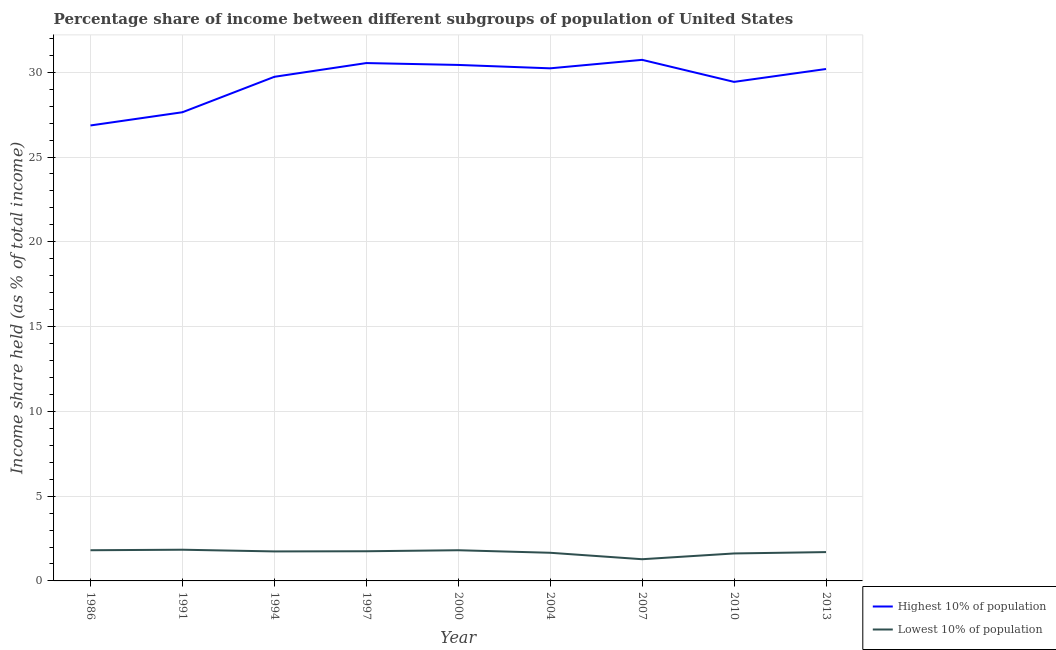Is the number of lines equal to the number of legend labels?
Your response must be concise. Yes. What is the income share held by lowest 10% of the population in 2004?
Ensure brevity in your answer.  1.66. Across all years, what is the maximum income share held by lowest 10% of the population?
Your answer should be very brief. 1.84. Across all years, what is the minimum income share held by highest 10% of the population?
Offer a terse response. 26.86. In which year was the income share held by highest 10% of the population maximum?
Give a very brief answer. 2007. What is the total income share held by highest 10% of the population in the graph?
Your answer should be very brief. 265.78. What is the difference between the income share held by highest 10% of the population in 2000 and that in 2013?
Offer a very short reply. 0.24. What is the difference between the income share held by lowest 10% of the population in 1997 and the income share held by highest 10% of the population in 2013?
Provide a short and direct response. -28.44. What is the average income share held by lowest 10% of the population per year?
Provide a succinct answer. 1.69. In the year 1994, what is the difference between the income share held by highest 10% of the population and income share held by lowest 10% of the population?
Make the answer very short. 27.99. What is the ratio of the income share held by lowest 10% of the population in 2010 to that in 2013?
Offer a terse response. 0.95. What is the difference between the highest and the second highest income share held by highest 10% of the population?
Your response must be concise. 0.19. What is the difference between the highest and the lowest income share held by highest 10% of the population?
Your answer should be very brief. 3.87. In how many years, is the income share held by highest 10% of the population greater than the average income share held by highest 10% of the population taken over all years?
Offer a terse response. 6. Does the income share held by highest 10% of the population monotonically increase over the years?
Offer a terse response. No. Is the income share held by highest 10% of the population strictly greater than the income share held by lowest 10% of the population over the years?
Give a very brief answer. Yes. Is the income share held by lowest 10% of the population strictly less than the income share held by highest 10% of the population over the years?
Make the answer very short. Yes. Are the values on the major ticks of Y-axis written in scientific E-notation?
Your response must be concise. No. Where does the legend appear in the graph?
Make the answer very short. Bottom right. How many legend labels are there?
Offer a very short reply. 2. What is the title of the graph?
Your response must be concise. Percentage share of income between different subgroups of population of United States. What is the label or title of the Y-axis?
Your response must be concise. Income share held (as % of total income). What is the Income share held (as % of total income) in Highest 10% of population in 1986?
Keep it short and to the point. 26.86. What is the Income share held (as % of total income) in Lowest 10% of population in 1986?
Provide a succinct answer. 1.81. What is the Income share held (as % of total income) in Highest 10% of population in 1991?
Ensure brevity in your answer.  27.64. What is the Income share held (as % of total income) of Lowest 10% of population in 1991?
Keep it short and to the point. 1.84. What is the Income share held (as % of total income) of Highest 10% of population in 1994?
Provide a short and direct response. 29.73. What is the Income share held (as % of total income) of Lowest 10% of population in 1994?
Your answer should be very brief. 1.74. What is the Income share held (as % of total income) of Highest 10% of population in 1997?
Provide a short and direct response. 30.54. What is the Income share held (as % of total income) of Lowest 10% of population in 1997?
Provide a short and direct response. 1.75. What is the Income share held (as % of total income) in Highest 10% of population in 2000?
Offer a very short reply. 30.43. What is the Income share held (as % of total income) in Lowest 10% of population in 2000?
Provide a succinct answer. 1.81. What is the Income share held (as % of total income) of Highest 10% of population in 2004?
Offer a terse response. 30.23. What is the Income share held (as % of total income) in Lowest 10% of population in 2004?
Provide a short and direct response. 1.66. What is the Income share held (as % of total income) in Highest 10% of population in 2007?
Ensure brevity in your answer.  30.73. What is the Income share held (as % of total income) in Lowest 10% of population in 2007?
Make the answer very short. 1.28. What is the Income share held (as % of total income) of Highest 10% of population in 2010?
Provide a short and direct response. 29.43. What is the Income share held (as % of total income) of Lowest 10% of population in 2010?
Ensure brevity in your answer.  1.62. What is the Income share held (as % of total income) in Highest 10% of population in 2013?
Provide a succinct answer. 30.19. Across all years, what is the maximum Income share held (as % of total income) in Highest 10% of population?
Keep it short and to the point. 30.73. Across all years, what is the maximum Income share held (as % of total income) of Lowest 10% of population?
Provide a short and direct response. 1.84. Across all years, what is the minimum Income share held (as % of total income) in Highest 10% of population?
Ensure brevity in your answer.  26.86. Across all years, what is the minimum Income share held (as % of total income) in Lowest 10% of population?
Make the answer very short. 1.28. What is the total Income share held (as % of total income) in Highest 10% of population in the graph?
Give a very brief answer. 265.78. What is the total Income share held (as % of total income) in Lowest 10% of population in the graph?
Provide a succinct answer. 15.21. What is the difference between the Income share held (as % of total income) of Highest 10% of population in 1986 and that in 1991?
Your answer should be compact. -0.78. What is the difference between the Income share held (as % of total income) in Lowest 10% of population in 1986 and that in 1991?
Offer a very short reply. -0.03. What is the difference between the Income share held (as % of total income) of Highest 10% of population in 1986 and that in 1994?
Offer a very short reply. -2.87. What is the difference between the Income share held (as % of total income) in Lowest 10% of population in 1986 and that in 1994?
Keep it short and to the point. 0.07. What is the difference between the Income share held (as % of total income) of Highest 10% of population in 1986 and that in 1997?
Your answer should be very brief. -3.68. What is the difference between the Income share held (as % of total income) of Lowest 10% of population in 1986 and that in 1997?
Offer a terse response. 0.06. What is the difference between the Income share held (as % of total income) in Highest 10% of population in 1986 and that in 2000?
Provide a short and direct response. -3.57. What is the difference between the Income share held (as % of total income) of Highest 10% of population in 1986 and that in 2004?
Offer a terse response. -3.37. What is the difference between the Income share held (as % of total income) in Highest 10% of population in 1986 and that in 2007?
Your answer should be very brief. -3.87. What is the difference between the Income share held (as % of total income) of Lowest 10% of population in 1986 and that in 2007?
Keep it short and to the point. 0.53. What is the difference between the Income share held (as % of total income) of Highest 10% of population in 1986 and that in 2010?
Offer a very short reply. -2.57. What is the difference between the Income share held (as % of total income) of Lowest 10% of population in 1986 and that in 2010?
Your response must be concise. 0.19. What is the difference between the Income share held (as % of total income) in Highest 10% of population in 1986 and that in 2013?
Offer a terse response. -3.33. What is the difference between the Income share held (as % of total income) of Lowest 10% of population in 1986 and that in 2013?
Give a very brief answer. 0.11. What is the difference between the Income share held (as % of total income) in Highest 10% of population in 1991 and that in 1994?
Keep it short and to the point. -2.09. What is the difference between the Income share held (as % of total income) of Lowest 10% of population in 1991 and that in 1994?
Give a very brief answer. 0.1. What is the difference between the Income share held (as % of total income) in Highest 10% of population in 1991 and that in 1997?
Your response must be concise. -2.9. What is the difference between the Income share held (as % of total income) of Lowest 10% of population in 1991 and that in 1997?
Offer a terse response. 0.09. What is the difference between the Income share held (as % of total income) in Highest 10% of population in 1991 and that in 2000?
Your response must be concise. -2.79. What is the difference between the Income share held (as % of total income) of Highest 10% of population in 1991 and that in 2004?
Your answer should be very brief. -2.59. What is the difference between the Income share held (as % of total income) of Lowest 10% of population in 1991 and that in 2004?
Offer a terse response. 0.18. What is the difference between the Income share held (as % of total income) of Highest 10% of population in 1991 and that in 2007?
Your response must be concise. -3.09. What is the difference between the Income share held (as % of total income) in Lowest 10% of population in 1991 and that in 2007?
Your answer should be very brief. 0.56. What is the difference between the Income share held (as % of total income) in Highest 10% of population in 1991 and that in 2010?
Make the answer very short. -1.79. What is the difference between the Income share held (as % of total income) in Lowest 10% of population in 1991 and that in 2010?
Make the answer very short. 0.22. What is the difference between the Income share held (as % of total income) of Highest 10% of population in 1991 and that in 2013?
Your answer should be compact. -2.55. What is the difference between the Income share held (as % of total income) in Lowest 10% of population in 1991 and that in 2013?
Your response must be concise. 0.14. What is the difference between the Income share held (as % of total income) in Highest 10% of population in 1994 and that in 1997?
Offer a very short reply. -0.81. What is the difference between the Income share held (as % of total income) in Lowest 10% of population in 1994 and that in 1997?
Offer a very short reply. -0.01. What is the difference between the Income share held (as % of total income) of Lowest 10% of population in 1994 and that in 2000?
Offer a terse response. -0.07. What is the difference between the Income share held (as % of total income) in Highest 10% of population in 1994 and that in 2004?
Offer a very short reply. -0.5. What is the difference between the Income share held (as % of total income) in Lowest 10% of population in 1994 and that in 2004?
Keep it short and to the point. 0.08. What is the difference between the Income share held (as % of total income) of Lowest 10% of population in 1994 and that in 2007?
Your answer should be compact. 0.46. What is the difference between the Income share held (as % of total income) in Highest 10% of population in 1994 and that in 2010?
Make the answer very short. 0.3. What is the difference between the Income share held (as % of total income) in Lowest 10% of population in 1994 and that in 2010?
Give a very brief answer. 0.12. What is the difference between the Income share held (as % of total income) of Highest 10% of population in 1994 and that in 2013?
Offer a terse response. -0.46. What is the difference between the Income share held (as % of total income) in Highest 10% of population in 1997 and that in 2000?
Provide a succinct answer. 0.11. What is the difference between the Income share held (as % of total income) in Lowest 10% of population in 1997 and that in 2000?
Offer a very short reply. -0.06. What is the difference between the Income share held (as % of total income) in Highest 10% of population in 1997 and that in 2004?
Make the answer very short. 0.31. What is the difference between the Income share held (as % of total income) of Lowest 10% of population in 1997 and that in 2004?
Your response must be concise. 0.09. What is the difference between the Income share held (as % of total income) in Highest 10% of population in 1997 and that in 2007?
Your response must be concise. -0.19. What is the difference between the Income share held (as % of total income) in Lowest 10% of population in 1997 and that in 2007?
Ensure brevity in your answer.  0.47. What is the difference between the Income share held (as % of total income) of Highest 10% of population in 1997 and that in 2010?
Give a very brief answer. 1.11. What is the difference between the Income share held (as % of total income) of Lowest 10% of population in 1997 and that in 2010?
Keep it short and to the point. 0.13. What is the difference between the Income share held (as % of total income) of Highest 10% of population in 1997 and that in 2013?
Offer a terse response. 0.35. What is the difference between the Income share held (as % of total income) in Lowest 10% of population in 1997 and that in 2013?
Give a very brief answer. 0.05. What is the difference between the Income share held (as % of total income) in Lowest 10% of population in 2000 and that in 2007?
Make the answer very short. 0.53. What is the difference between the Income share held (as % of total income) in Highest 10% of population in 2000 and that in 2010?
Provide a short and direct response. 1. What is the difference between the Income share held (as % of total income) in Lowest 10% of population in 2000 and that in 2010?
Your answer should be compact. 0.19. What is the difference between the Income share held (as % of total income) of Highest 10% of population in 2000 and that in 2013?
Make the answer very short. 0.24. What is the difference between the Income share held (as % of total income) of Lowest 10% of population in 2000 and that in 2013?
Your answer should be compact. 0.11. What is the difference between the Income share held (as % of total income) of Lowest 10% of population in 2004 and that in 2007?
Ensure brevity in your answer.  0.38. What is the difference between the Income share held (as % of total income) in Lowest 10% of population in 2004 and that in 2010?
Keep it short and to the point. 0.04. What is the difference between the Income share held (as % of total income) in Highest 10% of population in 2004 and that in 2013?
Provide a short and direct response. 0.04. What is the difference between the Income share held (as % of total income) of Lowest 10% of population in 2004 and that in 2013?
Make the answer very short. -0.04. What is the difference between the Income share held (as % of total income) of Lowest 10% of population in 2007 and that in 2010?
Ensure brevity in your answer.  -0.34. What is the difference between the Income share held (as % of total income) of Highest 10% of population in 2007 and that in 2013?
Your response must be concise. 0.54. What is the difference between the Income share held (as % of total income) in Lowest 10% of population in 2007 and that in 2013?
Provide a succinct answer. -0.42. What is the difference between the Income share held (as % of total income) in Highest 10% of population in 2010 and that in 2013?
Provide a short and direct response. -0.76. What is the difference between the Income share held (as % of total income) in Lowest 10% of population in 2010 and that in 2013?
Ensure brevity in your answer.  -0.08. What is the difference between the Income share held (as % of total income) in Highest 10% of population in 1986 and the Income share held (as % of total income) in Lowest 10% of population in 1991?
Your response must be concise. 25.02. What is the difference between the Income share held (as % of total income) of Highest 10% of population in 1986 and the Income share held (as % of total income) of Lowest 10% of population in 1994?
Keep it short and to the point. 25.12. What is the difference between the Income share held (as % of total income) in Highest 10% of population in 1986 and the Income share held (as % of total income) in Lowest 10% of population in 1997?
Your response must be concise. 25.11. What is the difference between the Income share held (as % of total income) in Highest 10% of population in 1986 and the Income share held (as % of total income) in Lowest 10% of population in 2000?
Offer a very short reply. 25.05. What is the difference between the Income share held (as % of total income) in Highest 10% of population in 1986 and the Income share held (as % of total income) in Lowest 10% of population in 2004?
Offer a terse response. 25.2. What is the difference between the Income share held (as % of total income) of Highest 10% of population in 1986 and the Income share held (as % of total income) of Lowest 10% of population in 2007?
Ensure brevity in your answer.  25.58. What is the difference between the Income share held (as % of total income) in Highest 10% of population in 1986 and the Income share held (as % of total income) in Lowest 10% of population in 2010?
Your response must be concise. 25.24. What is the difference between the Income share held (as % of total income) in Highest 10% of population in 1986 and the Income share held (as % of total income) in Lowest 10% of population in 2013?
Your answer should be compact. 25.16. What is the difference between the Income share held (as % of total income) of Highest 10% of population in 1991 and the Income share held (as % of total income) of Lowest 10% of population in 1994?
Give a very brief answer. 25.9. What is the difference between the Income share held (as % of total income) in Highest 10% of population in 1991 and the Income share held (as % of total income) in Lowest 10% of population in 1997?
Your answer should be very brief. 25.89. What is the difference between the Income share held (as % of total income) of Highest 10% of population in 1991 and the Income share held (as % of total income) of Lowest 10% of population in 2000?
Keep it short and to the point. 25.83. What is the difference between the Income share held (as % of total income) of Highest 10% of population in 1991 and the Income share held (as % of total income) of Lowest 10% of population in 2004?
Your response must be concise. 25.98. What is the difference between the Income share held (as % of total income) of Highest 10% of population in 1991 and the Income share held (as % of total income) of Lowest 10% of population in 2007?
Provide a short and direct response. 26.36. What is the difference between the Income share held (as % of total income) of Highest 10% of population in 1991 and the Income share held (as % of total income) of Lowest 10% of population in 2010?
Offer a terse response. 26.02. What is the difference between the Income share held (as % of total income) in Highest 10% of population in 1991 and the Income share held (as % of total income) in Lowest 10% of population in 2013?
Offer a very short reply. 25.94. What is the difference between the Income share held (as % of total income) of Highest 10% of population in 1994 and the Income share held (as % of total income) of Lowest 10% of population in 1997?
Offer a terse response. 27.98. What is the difference between the Income share held (as % of total income) of Highest 10% of population in 1994 and the Income share held (as % of total income) of Lowest 10% of population in 2000?
Provide a short and direct response. 27.92. What is the difference between the Income share held (as % of total income) in Highest 10% of population in 1994 and the Income share held (as % of total income) in Lowest 10% of population in 2004?
Provide a short and direct response. 28.07. What is the difference between the Income share held (as % of total income) of Highest 10% of population in 1994 and the Income share held (as % of total income) of Lowest 10% of population in 2007?
Give a very brief answer. 28.45. What is the difference between the Income share held (as % of total income) of Highest 10% of population in 1994 and the Income share held (as % of total income) of Lowest 10% of population in 2010?
Ensure brevity in your answer.  28.11. What is the difference between the Income share held (as % of total income) in Highest 10% of population in 1994 and the Income share held (as % of total income) in Lowest 10% of population in 2013?
Offer a terse response. 28.03. What is the difference between the Income share held (as % of total income) of Highest 10% of population in 1997 and the Income share held (as % of total income) of Lowest 10% of population in 2000?
Give a very brief answer. 28.73. What is the difference between the Income share held (as % of total income) of Highest 10% of population in 1997 and the Income share held (as % of total income) of Lowest 10% of population in 2004?
Give a very brief answer. 28.88. What is the difference between the Income share held (as % of total income) of Highest 10% of population in 1997 and the Income share held (as % of total income) of Lowest 10% of population in 2007?
Your answer should be compact. 29.26. What is the difference between the Income share held (as % of total income) in Highest 10% of population in 1997 and the Income share held (as % of total income) in Lowest 10% of population in 2010?
Make the answer very short. 28.92. What is the difference between the Income share held (as % of total income) in Highest 10% of population in 1997 and the Income share held (as % of total income) in Lowest 10% of population in 2013?
Your response must be concise. 28.84. What is the difference between the Income share held (as % of total income) in Highest 10% of population in 2000 and the Income share held (as % of total income) in Lowest 10% of population in 2004?
Make the answer very short. 28.77. What is the difference between the Income share held (as % of total income) of Highest 10% of population in 2000 and the Income share held (as % of total income) of Lowest 10% of population in 2007?
Your answer should be compact. 29.15. What is the difference between the Income share held (as % of total income) of Highest 10% of population in 2000 and the Income share held (as % of total income) of Lowest 10% of population in 2010?
Offer a terse response. 28.81. What is the difference between the Income share held (as % of total income) of Highest 10% of population in 2000 and the Income share held (as % of total income) of Lowest 10% of population in 2013?
Provide a succinct answer. 28.73. What is the difference between the Income share held (as % of total income) in Highest 10% of population in 2004 and the Income share held (as % of total income) in Lowest 10% of population in 2007?
Offer a terse response. 28.95. What is the difference between the Income share held (as % of total income) of Highest 10% of population in 2004 and the Income share held (as % of total income) of Lowest 10% of population in 2010?
Offer a terse response. 28.61. What is the difference between the Income share held (as % of total income) of Highest 10% of population in 2004 and the Income share held (as % of total income) of Lowest 10% of population in 2013?
Your answer should be very brief. 28.53. What is the difference between the Income share held (as % of total income) of Highest 10% of population in 2007 and the Income share held (as % of total income) of Lowest 10% of population in 2010?
Give a very brief answer. 29.11. What is the difference between the Income share held (as % of total income) of Highest 10% of population in 2007 and the Income share held (as % of total income) of Lowest 10% of population in 2013?
Provide a short and direct response. 29.03. What is the difference between the Income share held (as % of total income) of Highest 10% of population in 2010 and the Income share held (as % of total income) of Lowest 10% of population in 2013?
Your answer should be compact. 27.73. What is the average Income share held (as % of total income) in Highest 10% of population per year?
Your answer should be very brief. 29.53. What is the average Income share held (as % of total income) of Lowest 10% of population per year?
Keep it short and to the point. 1.69. In the year 1986, what is the difference between the Income share held (as % of total income) in Highest 10% of population and Income share held (as % of total income) in Lowest 10% of population?
Give a very brief answer. 25.05. In the year 1991, what is the difference between the Income share held (as % of total income) in Highest 10% of population and Income share held (as % of total income) in Lowest 10% of population?
Offer a terse response. 25.8. In the year 1994, what is the difference between the Income share held (as % of total income) in Highest 10% of population and Income share held (as % of total income) in Lowest 10% of population?
Your response must be concise. 27.99. In the year 1997, what is the difference between the Income share held (as % of total income) of Highest 10% of population and Income share held (as % of total income) of Lowest 10% of population?
Offer a very short reply. 28.79. In the year 2000, what is the difference between the Income share held (as % of total income) of Highest 10% of population and Income share held (as % of total income) of Lowest 10% of population?
Ensure brevity in your answer.  28.62. In the year 2004, what is the difference between the Income share held (as % of total income) of Highest 10% of population and Income share held (as % of total income) of Lowest 10% of population?
Offer a terse response. 28.57. In the year 2007, what is the difference between the Income share held (as % of total income) in Highest 10% of population and Income share held (as % of total income) in Lowest 10% of population?
Provide a short and direct response. 29.45. In the year 2010, what is the difference between the Income share held (as % of total income) in Highest 10% of population and Income share held (as % of total income) in Lowest 10% of population?
Offer a terse response. 27.81. In the year 2013, what is the difference between the Income share held (as % of total income) in Highest 10% of population and Income share held (as % of total income) in Lowest 10% of population?
Provide a succinct answer. 28.49. What is the ratio of the Income share held (as % of total income) in Highest 10% of population in 1986 to that in 1991?
Make the answer very short. 0.97. What is the ratio of the Income share held (as % of total income) of Lowest 10% of population in 1986 to that in 1991?
Ensure brevity in your answer.  0.98. What is the ratio of the Income share held (as % of total income) of Highest 10% of population in 1986 to that in 1994?
Offer a terse response. 0.9. What is the ratio of the Income share held (as % of total income) of Lowest 10% of population in 1986 to that in 1994?
Your answer should be very brief. 1.04. What is the ratio of the Income share held (as % of total income) in Highest 10% of population in 1986 to that in 1997?
Offer a terse response. 0.88. What is the ratio of the Income share held (as % of total income) in Lowest 10% of population in 1986 to that in 1997?
Offer a very short reply. 1.03. What is the ratio of the Income share held (as % of total income) in Highest 10% of population in 1986 to that in 2000?
Make the answer very short. 0.88. What is the ratio of the Income share held (as % of total income) in Lowest 10% of population in 1986 to that in 2000?
Make the answer very short. 1. What is the ratio of the Income share held (as % of total income) of Highest 10% of population in 1986 to that in 2004?
Offer a terse response. 0.89. What is the ratio of the Income share held (as % of total income) of Lowest 10% of population in 1986 to that in 2004?
Give a very brief answer. 1.09. What is the ratio of the Income share held (as % of total income) in Highest 10% of population in 1986 to that in 2007?
Keep it short and to the point. 0.87. What is the ratio of the Income share held (as % of total income) in Lowest 10% of population in 1986 to that in 2007?
Your answer should be compact. 1.41. What is the ratio of the Income share held (as % of total income) in Highest 10% of population in 1986 to that in 2010?
Your answer should be compact. 0.91. What is the ratio of the Income share held (as % of total income) in Lowest 10% of population in 1986 to that in 2010?
Your response must be concise. 1.12. What is the ratio of the Income share held (as % of total income) in Highest 10% of population in 1986 to that in 2013?
Keep it short and to the point. 0.89. What is the ratio of the Income share held (as % of total income) of Lowest 10% of population in 1986 to that in 2013?
Your response must be concise. 1.06. What is the ratio of the Income share held (as % of total income) in Highest 10% of population in 1991 to that in 1994?
Make the answer very short. 0.93. What is the ratio of the Income share held (as % of total income) in Lowest 10% of population in 1991 to that in 1994?
Offer a very short reply. 1.06. What is the ratio of the Income share held (as % of total income) in Highest 10% of population in 1991 to that in 1997?
Ensure brevity in your answer.  0.91. What is the ratio of the Income share held (as % of total income) of Lowest 10% of population in 1991 to that in 1997?
Your response must be concise. 1.05. What is the ratio of the Income share held (as % of total income) of Highest 10% of population in 1991 to that in 2000?
Your answer should be very brief. 0.91. What is the ratio of the Income share held (as % of total income) of Lowest 10% of population in 1991 to that in 2000?
Offer a terse response. 1.02. What is the ratio of the Income share held (as % of total income) of Highest 10% of population in 1991 to that in 2004?
Your answer should be compact. 0.91. What is the ratio of the Income share held (as % of total income) in Lowest 10% of population in 1991 to that in 2004?
Keep it short and to the point. 1.11. What is the ratio of the Income share held (as % of total income) in Highest 10% of population in 1991 to that in 2007?
Your answer should be very brief. 0.9. What is the ratio of the Income share held (as % of total income) of Lowest 10% of population in 1991 to that in 2007?
Offer a terse response. 1.44. What is the ratio of the Income share held (as % of total income) in Highest 10% of population in 1991 to that in 2010?
Ensure brevity in your answer.  0.94. What is the ratio of the Income share held (as % of total income) in Lowest 10% of population in 1991 to that in 2010?
Your response must be concise. 1.14. What is the ratio of the Income share held (as % of total income) in Highest 10% of population in 1991 to that in 2013?
Keep it short and to the point. 0.92. What is the ratio of the Income share held (as % of total income) in Lowest 10% of population in 1991 to that in 2013?
Ensure brevity in your answer.  1.08. What is the ratio of the Income share held (as % of total income) in Highest 10% of population in 1994 to that in 1997?
Ensure brevity in your answer.  0.97. What is the ratio of the Income share held (as % of total income) of Lowest 10% of population in 1994 to that in 2000?
Keep it short and to the point. 0.96. What is the ratio of the Income share held (as % of total income) of Highest 10% of population in 1994 to that in 2004?
Give a very brief answer. 0.98. What is the ratio of the Income share held (as % of total income) of Lowest 10% of population in 1994 to that in 2004?
Provide a short and direct response. 1.05. What is the ratio of the Income share held (as % of total income) in Highest 10% of population in 1994 to that in 2007?
Ensure brevity in your answer.  0.97. What is the ratio of the Income share held (as % of total income) of Lowest 10% of population in 1994 to that in 2007?
Provide a short and direct response. 1.36. What is the ratio of the Income share held (as % of total income) of Highest 10% of population in 1994 to that in 2010?
Your response must be concise. 1.01. What is the ratio of the Income share held (as % of total income) in Lowest 10% of population in 1994 to that in 2010?
Offer a very short reply. 1.07. What is the ratio of the Income share held (as % of total income) of Lowest 10% of population in 1994 to that in 2013?
Offer a terse response. 1.02. What is the ratio of the Income share held (as % of total income) of Lowest 10% of population in 1997 to that in 2000?
Offer a very short reply. 0.97. What is the ratio of the Income share held (as % of total income) in Highest 10% of population in 1997 to that in 2004?
Make the answer very short. 1.01. What is the ratio of the Income share held (as % of total income) of Lowest 10% of population in 1997 to that in 2004?
Make the answer very short. 1.05. What is the ratio of the Income share held (as % of total income) in Lowest 10% of population in 1997 to that in 2007?
Keep it short and to the point. 1.37. What is the ratio of the Income share held (as % of total income) in Highest 10% of population in 1997 to that in 2010?
Provide a short and direct response. 1.04. What is the ratio of the Income share held (as % of total income) in Lowest 10% of population in 1997 to that in 2010?
Keep it short and to the point. 1.08. What is the ratio of the Income share held (as % of total income) of Highest 10% of population in 1997 to that in 2013?
Offer a terse response. 1.01. What is the ratio of the Income share held (as % of total income) in Lowest 10% of population in 1997 to that in 2013?
Your answer should be very brief. 1.03. What is the ratio of the Income share held (as % of total income) in Highest 10% of population in 2000 to that in 2004?
Keep it short and to the point. 1.01. What is the ratio of the Income share held (as % of total income) of Lowest 10% of population in 2000 to that in 2004?
Your answer should be very brief. 1.09. What is the ratio of the Income share held (as % of total income) in Highest 10% of population in 2000 to that in 2007?
Your answer should be very brief. 0.99. What is the ratio of the Income share held (as % of total income) of Lowest 10% of population in 2000 to that in 2007?
Your response must be concise. 1.41. What is the ratio of the Income share held (as % of total income) in Highest 10% of population in 2000 to that in 2010?
Offer a terse response. 1.03. What is the ratio of the Income share held (as % of total income) in Lowest 10% of population in 2000 to that in 2010?
Your response must be concise. 1.12. What is the ratio of the Income share held (as % of total income) in Highest 10% of population in 2000 to that in 2013?
Provide a succinct answer. 1.01. What is the ratio of the Income share held (as % of total income) of Lowest 10% of population in 2000 to that in 2013?
Your answer should be compact. 1.06. What is the ratio of the Income share held (as % of total income) of Highest 10% of population in 2004 to that in 2007?
Your answer should be compact. 0.98. What is the ratio of the Income share held (as % of total income) of Lowest 10% of population in 2004 to that in 2007?
Your response must be concise. 1.3. What is the ratio of the Income share held (as % of total income) in Highest 10% of population in 2004 to that in 2010?
Provide a short and direct response. 1.03. What is the ratio of the Income share held (as % of total income) of Lowest 10% of population in 2004 to that in 2010?
Your answer should be compact. 1.02. What is the ratio of the Income share held (as % of total income) of Highest 10% of population in 2004 to that in 2013?
Keep it short and to the point. 1. What is the ratio of the Income share held (as % of total income) of Lowest 10% of population in 2004 to that in 2013?
Make the answer very short. 0.98. What is the ratio of the Income share held (as % of total income) in Highest 10% of population in 2007 to that in 2010?
Provide a succinct answer. 1.04. What is the ratio of the Income share held (as % of total income) of Lowest 10% of population in 2007 to that in 2010?
Provide a succinct answer. 0.79. What is the ratio of the Income share held (as % of total income) in Highest 10% of population in 2007 to that in 2013?
Ensure brevity in your answer.  1.02. What is the ratio of the Income share held (as % of total income) of Lowest 10% of population in 2007 to that in 2013?
Provide a short and direct response. 0.75. What is the ratio of the Income share held (as % of total income) of Highest 10% of population in 2010 to that in 2013?
Give a very brief answer. 0.97. What is the ratio of the Income share held (as % of total income) of Lowest 10% of population in 2010 to that in 2013?
Offer a very short reply. 0.95. What is the difference between the highest and the second highest Income share held (as % of total income) in Highest 10% of population?
Provide a succinct answer. 0.19. What is the difference between the highest and the second highest Income share held (as % of total income) of Lowest 10% of population?
Ensure brevity in your answer.  0.03. What is the difference between the highest and the lowest Income share held (as % of total income) in Highest 10% of population?
Give a very brief answer. 3.87. What is the difference between the highest and the lowest Income share held (as % of total income) in Lowest 10% of population?
Keep it short and to the point. 0.56. 